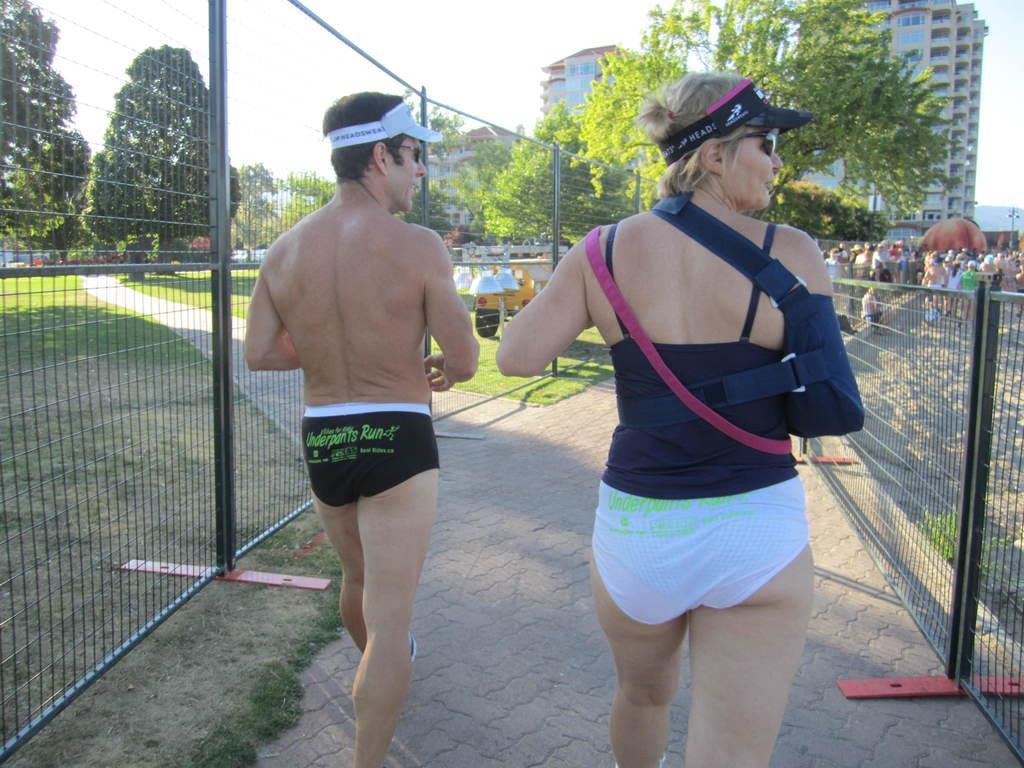In one or two sentences, can you explain what this image depicts? Here is the man and the woman walking on the pathway. These look like barricades. These are the trees and buildings. I can see groups of people standing. 